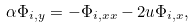<formula> <loc_0><loc_0><loc_500><loc_500>\alpha \Phi _ { i , y } = - \Phi _ { i , x x } - 2 u \Phi _ { i , x } ,</formula> 